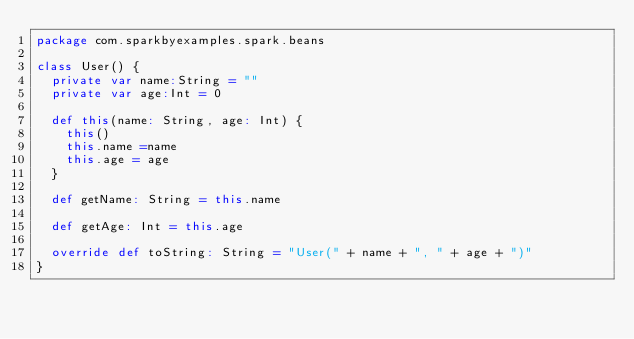Convert code to text. <code><loc_0><loc_0><loc_500><loc_500><_Scala_>package com.sparkbyexamples.spark.beans

class User() {
  private var name:String = ""
  private var age:Int = 0

  def this(name: String, age: Int) {
    this()
    this.name =name
    this.age = age
  }

  def getName: String = this.name

  def getAge: Int = this.age

  override def toString: String = "User(" + name + ", " + age + ")"
}
</code> 